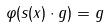<formula> <loc_0><loc_0><loc_500><loc_500>\varphi ( s ( x ) \cdot g ) = g</formula> 